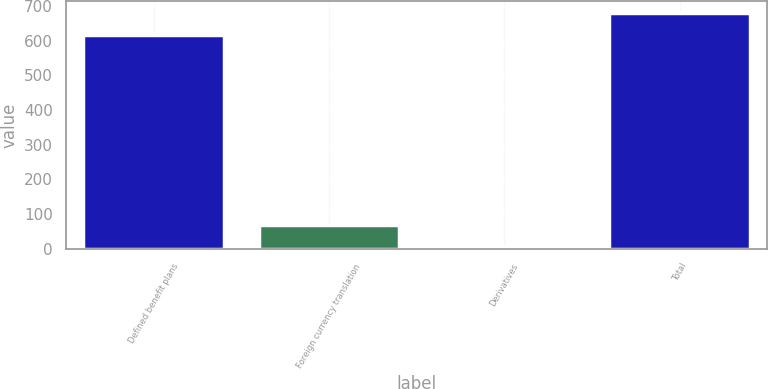<chart> <loc_0><loc_0><loc_500><loc_500><bar_chart><fcel>Defined benefit plans<fcel>Foreign currency translation<fcel>Derivatives<fcel>Total<nl><fcel>615<fcel>69<fcel>4<fcel>680<nl></chart> 